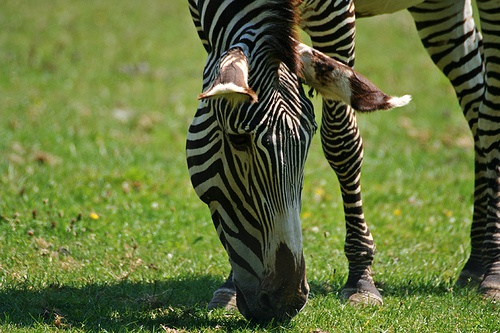Describe the objects in this image and their specific colors. I can see a zebra in olive, black, darkgreen, and gray tones in this image. 